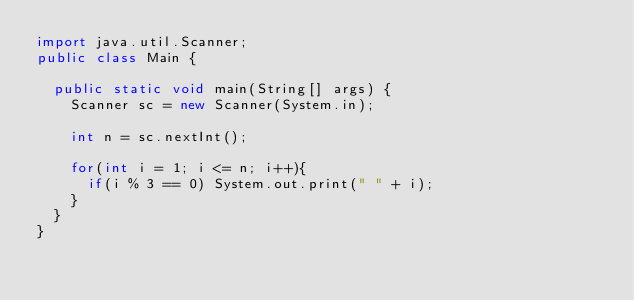Convert code to text. <code><loc_0><loc_0><loc_500><loc_500><_Java_>import java.util.Scanner;
public class Main {

	public static void main(String[] args) {
		Scanner sc = new Scanner(System.in);
		
		int n = sc.nextInt();
		
		for(int i = 1; i <= n; i++){
			if(i % 3 == 0) System.out.print(" " + i);
		}
	}
}
</code> 